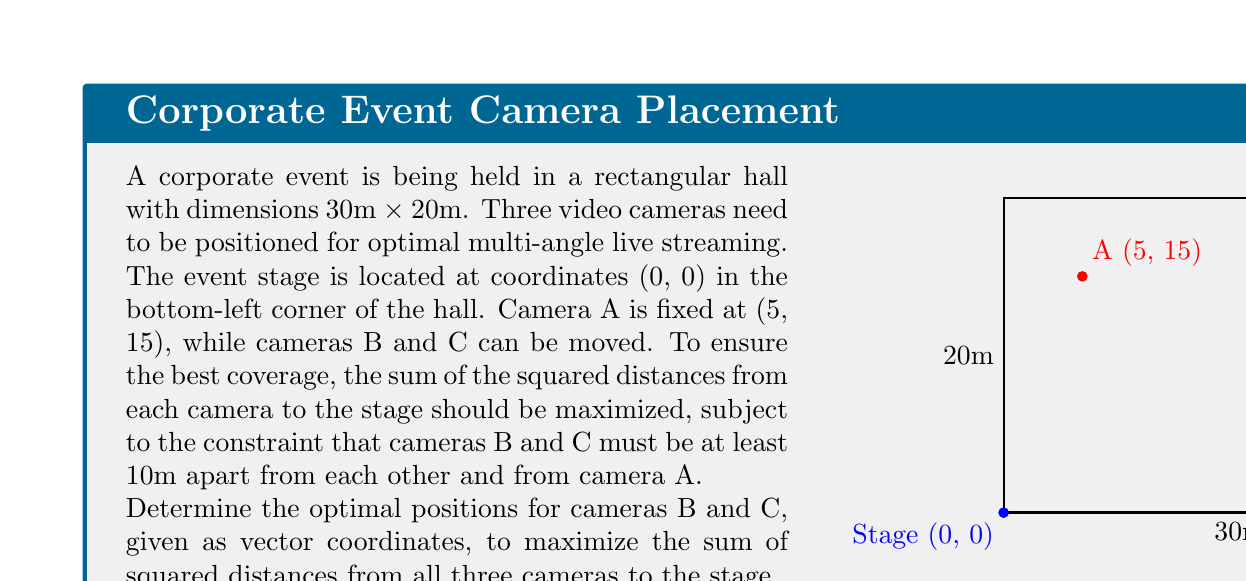Provide a solution to this math problem. Let's approach this step-by-step:

1) First, we need to express the objective function. The sum of squared distances from each camera to the stage (0, 0) is:

   $$ f(x_1, y_1, x_2, y_2) = (5^2 + 15^2) + (x_1^2 + y_1^2) + (x_2^2 + y_2^2) $$

   where $(x_1, y_1)$ and $(x_2, y_2)$ are the coordinates of cameras B and C respectively.

2) The constraints are:
   - Cameras B and C must be at least 10m apart from each other:
     $$ \sqrt{(x_1 - x_2)^2 + (y_1 - y_2)^2} \geq 10 $$
   - Cameras B and C must be at least 10m apart from camera A:
     $$ \sqrt{(x_1 - 5)^2 + (y_1 - 15)^2} \geq 10 $$
     $$ \sqrt{(x_2 - 5)^2 + (y_2 - 15)^2} \geq 10 $$
   - Cameras B and C must be within the hall:
     $$ 0 \leq x_1, x_2 \leq 30 $$
     $$ 0 \leq y_1, y_2 \leq 20 $$

3) To maximize the sum of squared distances, we should place cameras B and C as far from the stage as possible while satisfying the constraints.

4) The farthest corners from the stage (0, 0) are (30, 20) and (0, 20).

5) Placing camera B at (30, 20) and camera C at (0, 20) satisfies all constraints:
   - They are 30m apart from each other.
   - They are both more than 10m away from camera A.
   - They are within the hall boundaries.

6) This placement maximizes the objective function:

   $$ f(30, 20, 0, 20) = (5^2 + 15^2) + (30^2 + 20^2) + (0^2 + 20^2) = 2250 $$

Therefore, the optimal positions for cameras B and C are (30, 20) and (0, 20) respectively.
Answer: $$B(30, 20), C(0, 20)$$ 